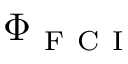Convert formula to latex. <formula><loc_0><loc_0><loc_500><loc_500>\Phi _ { F C I }</formula> 